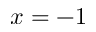<formula> <loc_0><loc_0><loc_500><loc_500>x = - 1</formula> 